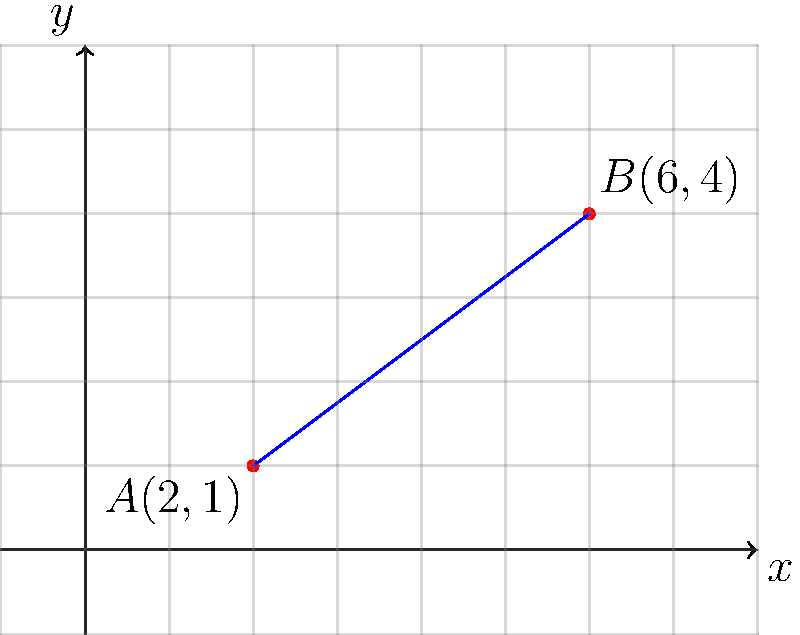In the coordinate plane above, a line passes through points $A(2,1)$ and $B(6,4)$. This line could represent the rising arc of a character's journey in a novel. Determine the slope of this line, which might symbolize the rate of character development. How would you describe this slope to an aspiring writer in terms of pacing in storytelling? To find the slope of the line passing through points $A(2,1)$ and $B(6,4)$, we'll use the slope formula:

$$ m = \frac{y_2 - y_1}{x_2 - x_1} $$

Where $(x_1, y_1)$ represents the coordinates of point $A$, and $(x_2, y_2)$ represents the coordinates of point $B$.

Step 1: Identify the coordinates
$A: (x_1, y_1) = (2, 1)$
$B: (x_2, y_2) = (6, 4)$

Step 2: Substitute these values into the slope formula
$$ m = \frac{4 - 1}{6 - 2} = \frac{3}{4} = 0.75 $$

Step 3: Interpret the result
The slope of $\frac{3}{4}$ or $0.75$ indicates a moderate, steady increase. In terms of storytelling, this could be described to an aspiring writer as a consistent and gradual character development. The character is growing and changing at a steady pace, neither too quickly nor too slowly. This slope suggests a well-paced narrative where the reader has time to absorb changes in the character while maintaining interest in their progression.
Answer: $\frac{3}{4}$ or $0.75$ 